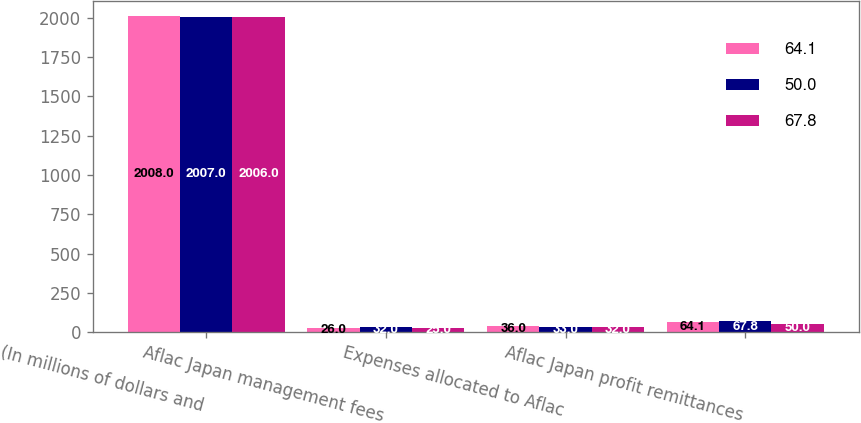<chart> <loc_0><loc_0><loc_500><loc_500><stacked_bar_chart><ecel><fcel>(In millions of dollars and<fcel>Aflac Japan management fees<fcel>Expenses allocated to Aflac<fcel>Aflac Japan profit remittances<nl><fcel>64.1<fcel>2008<fcel>26<fcel>36<fcel>64.1<nl><fcel>50<fcel>2007<fcel>32<fcel>33<fcel>67.8<nl><fcel>67.8<fcel>2006<fcel>25<fcel>32<fcel>50<nl></chart> 